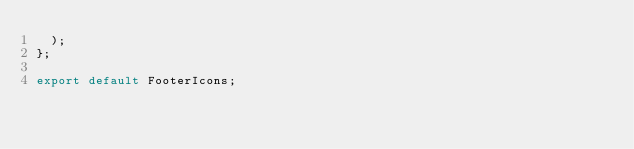Convert code to text. <code><loc_0><loc_0><loc_500><loc_500><_JavaScript_>  );
};

export default FooterIcons;
</code> 